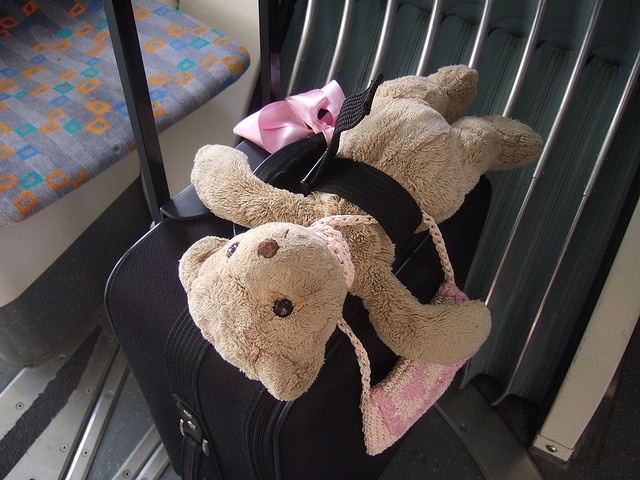Describe the objects in this image and their specific colors. I can see teddy bear in black, gray, and tan tones, suitcase in black, gray, and darkgray tones, chair in black and gray tones, and handbag in black, gray, salmon, and lightpink tones in this image. 